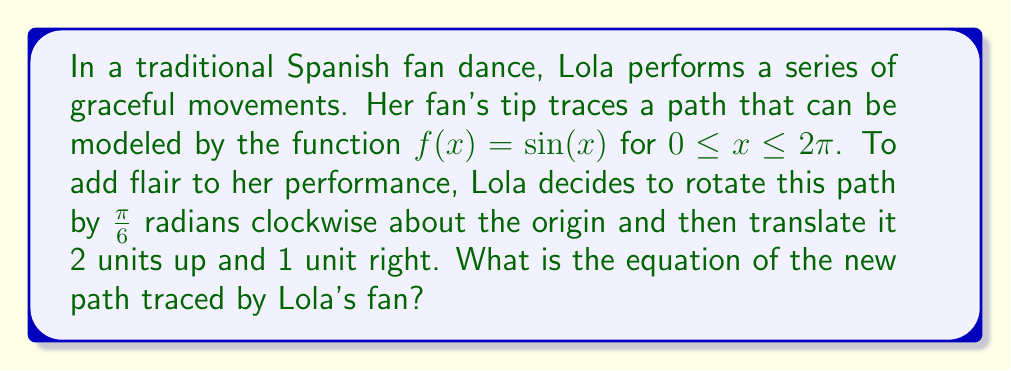What is the answer to this math problem? 1. Start with the original function: $f(x) = \sin(x)$

2. To rotate the function clockwise by $\frac{\pi}{6}$ radians about the origin, we use the rotation formulas:
   $x' = x\cos(\theta) + y\sin(\theta)$
   $y' = -x\sin(\theta) + y\cos(\theta)$
   where $\theta = \frac{\pi}{6}$

3. Substitute $y = \sin(x)$ into these formulas:
   $x' = x\cos(\frac{\pi}{6}) + \sin(x)\sin(\frac{\pi}{6})$
   $y' = -x\sin(\frac{\pi}{6}) + \sin(x)\cos(\frac{\pi}{6})$

4. To express $y'$ in terms of $x'$, we need to solve for $x$ and $\sin(x)$ in terms of $x'$:
   $x = x'\cos(\frac{\pi}{6}) - y'\sin(\frac{\pi}{6})$
   $\sin(x) = x'\sin(\frac{\pi}{6}) + y'\cos(\frac{\pi}{6})$

5. Substitute these expressions into the equation for $y'$:
   $y' = -(x'\cos(\frac{\pi}{6}) - y'\sin(\frac{\pi}{6}))\sin(\frac{\pi}{6}) + (x'\sin(\frac{\pi}{6}) + y'\cos(\frac{\pi}{6}))\cos(\frac{\pi}{6})$

6. Simplify and solve for $y'$:
   $y' = x'\sin(\frac{\pi}{6})\cos(\frac{\pi}{6}) + x'\sin(\frac{\pi}{6})\cos(\frac{\pi}{6}) = x'\sin(\frac{\pi}{3})$

7. Now, to translate the function 2 units up and 1 unit right, we add 2 to $y'$ and subtract 1 from $x'$:
   $y' = (x'+1)\sin(\frac{\pi}{3}) + 2$

8. Rename $x'$ as $x$ and $y'$ as $y$ for the final equation:
   $y = (x+1)\sin(\frac{\pi}{3}) + 2$
Answer: $y = (x+1)\sin(\frac{\pi}{3}) + 2$ 